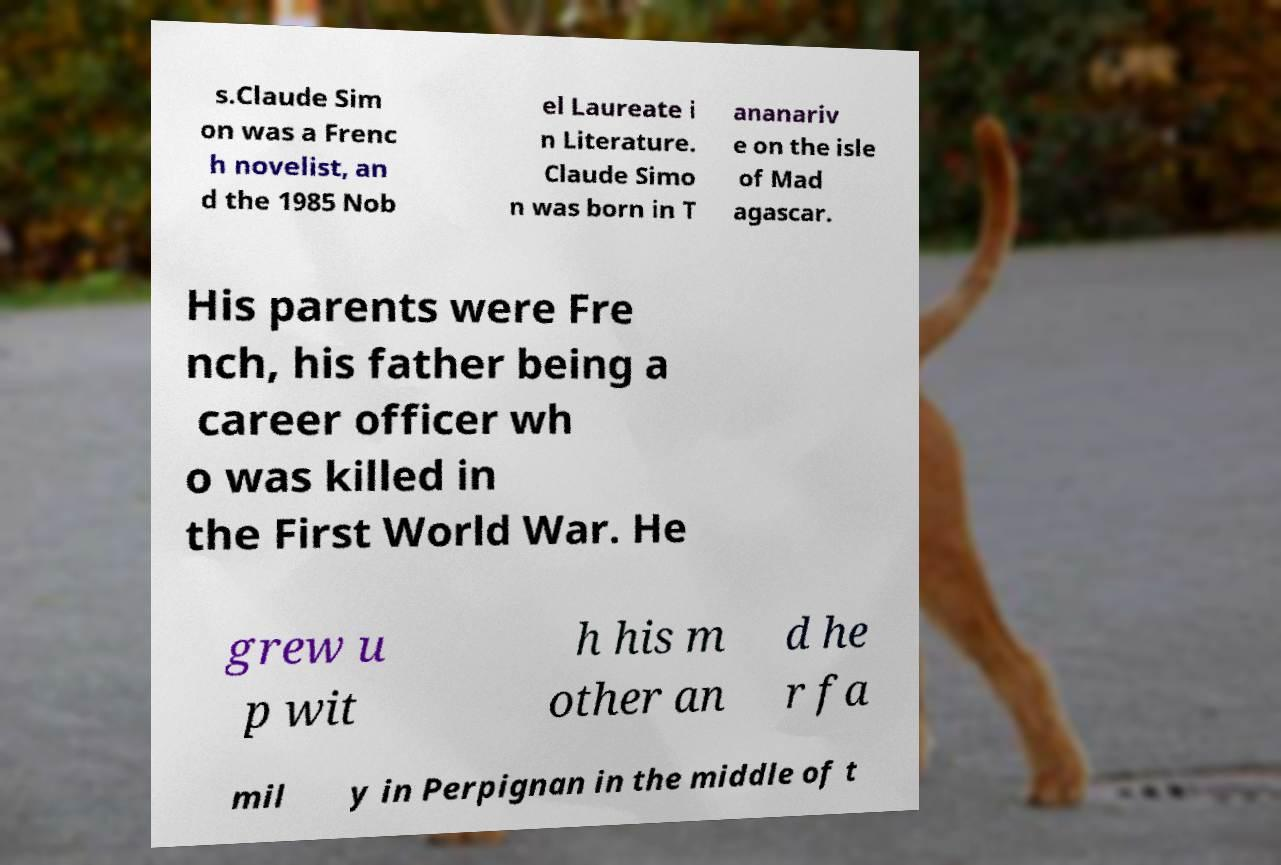What messages or text are displayed in this image? I need them in a readable, typed format. s.Claude Sim on was a Frenc h novelist, an d the 1985 Nob el Laureate i n Literature. Claude Simo n was born in T ananariv e on the isle of Mad agascar. His parents were Fre nch, his father being a career officer wh o was killed in the First World War. He grew u p wit h his m other an d he r fa mil y in Perpignan in the middle of t 